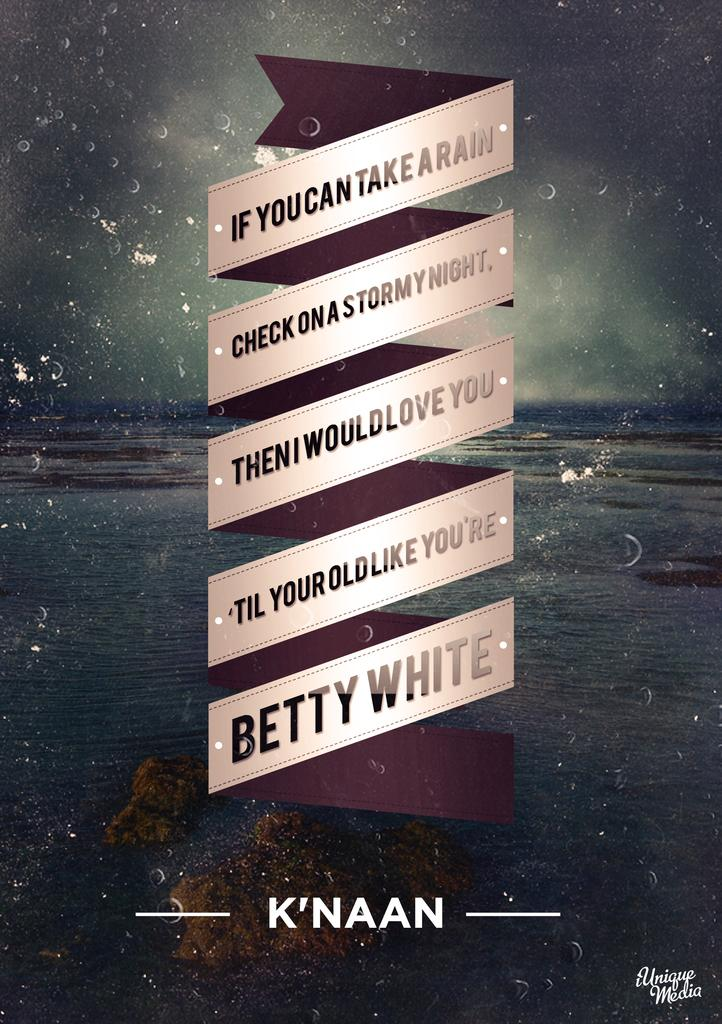<image>
Give a short and clear explanation of the subsequent image. A poster for K'NAAN is displayed from Unique Media. 